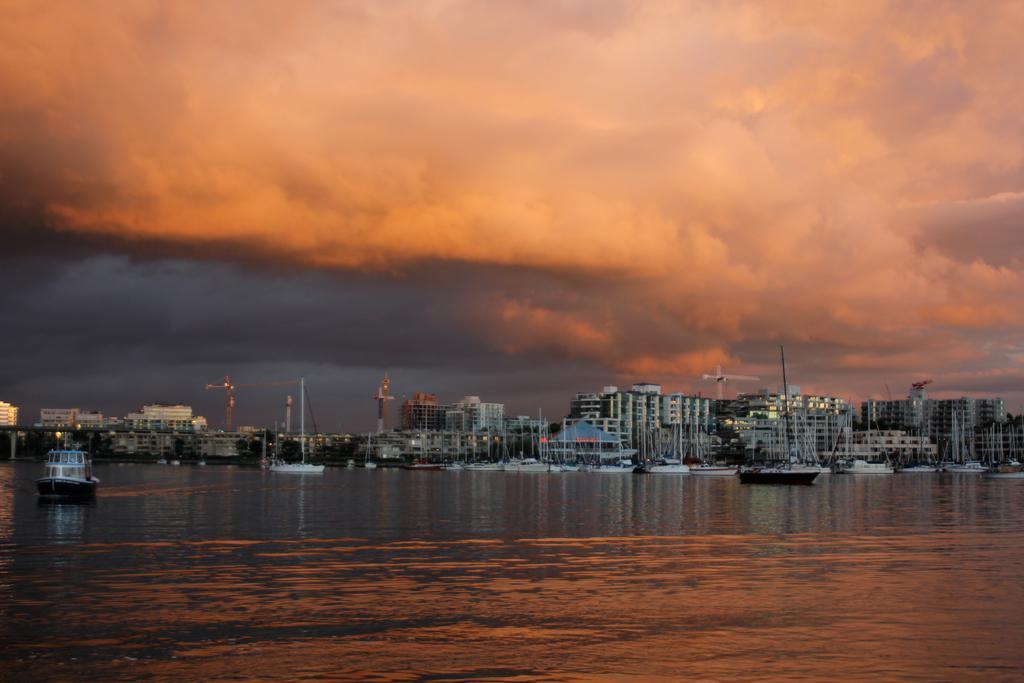Describe this image in one or two sentences. In the center of the image there are buildings. At the bottom there is water and we can see boats on the water. In the background there is sky. 